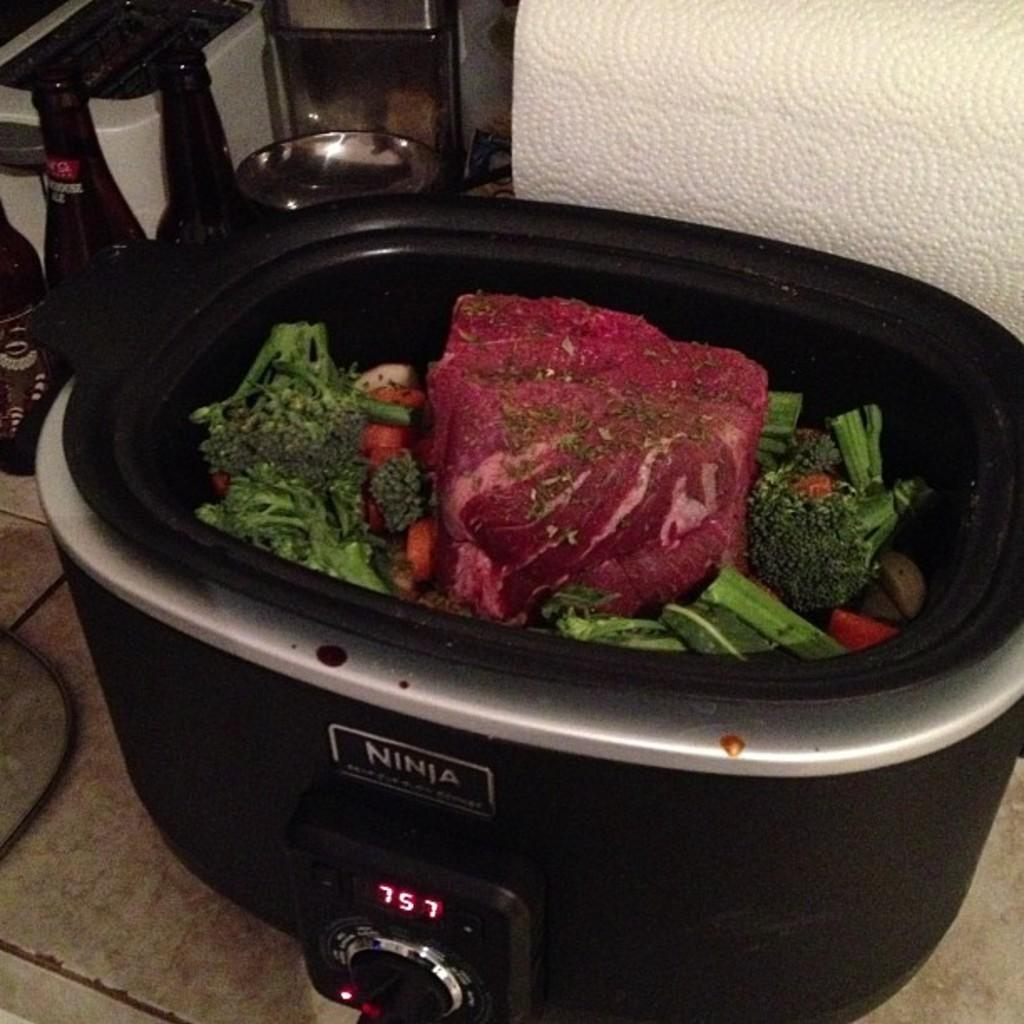What is in the bowl that is visible in the image? There are food items in a bowl in the image. What else can be seen in the image besides the bowl? There is a bottle and a wire visible in the image. What might be the contents of the bottle? The contents of the bottle cannot be determined from the image. What can be seen in the background of the image? There are objects visible in the background of the image. What is the purpose of the gun in the image? There is no gun present in the image. 